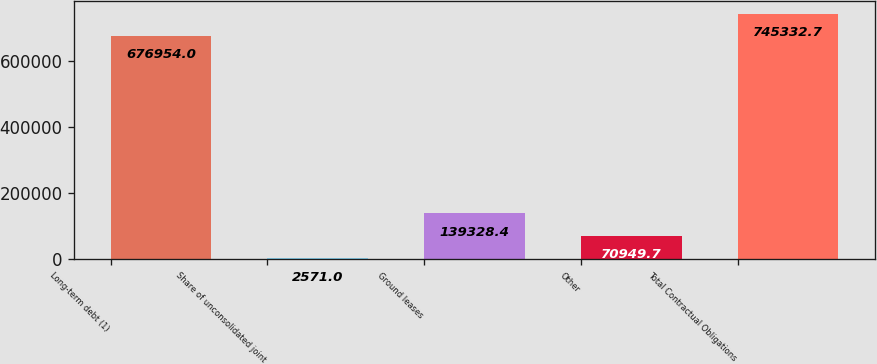<chart> <loc_0><loc_0><loc_500><loc_500><bar_chart><fcel>Long-term debt (1)<fcel>Share of unconsolidated joint<fcel>Ground leases<fcel>Other<fcel>Total Contractual Obligations<nl><fcel>676954<fcel>2571<fcel>139328<fcel>70949.7<fcel>745333<nl></chart> 